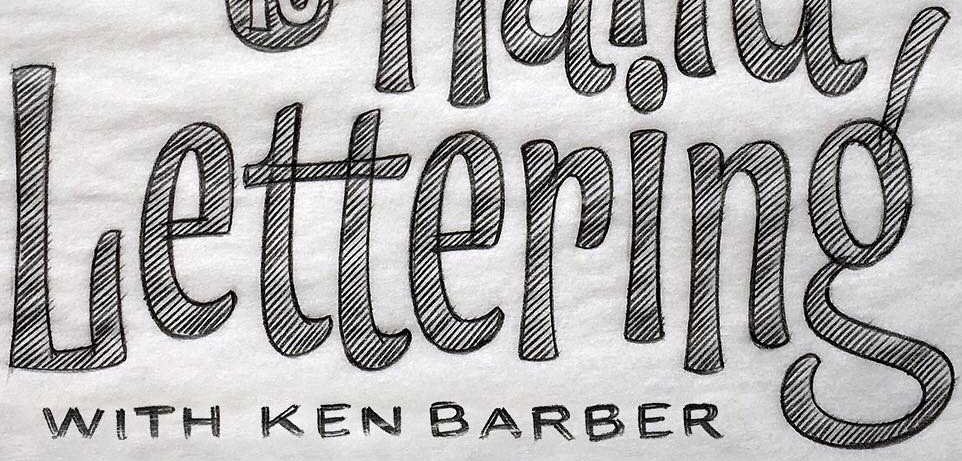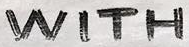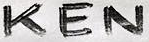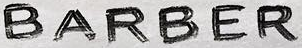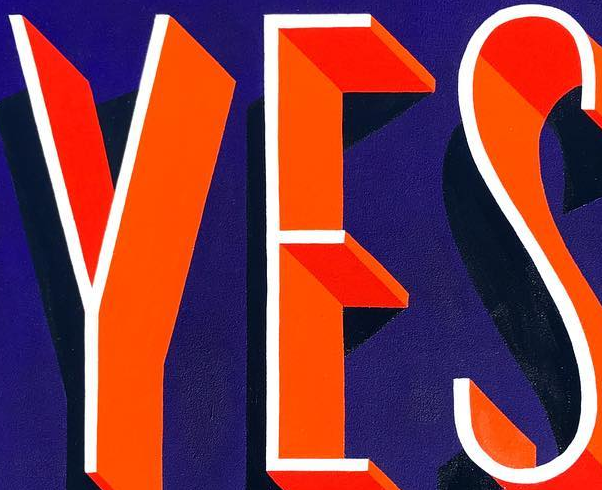What text appears in these images from left to right, separated by a semicolon? Lettering'; WITH; KEN; BARBER; YES 